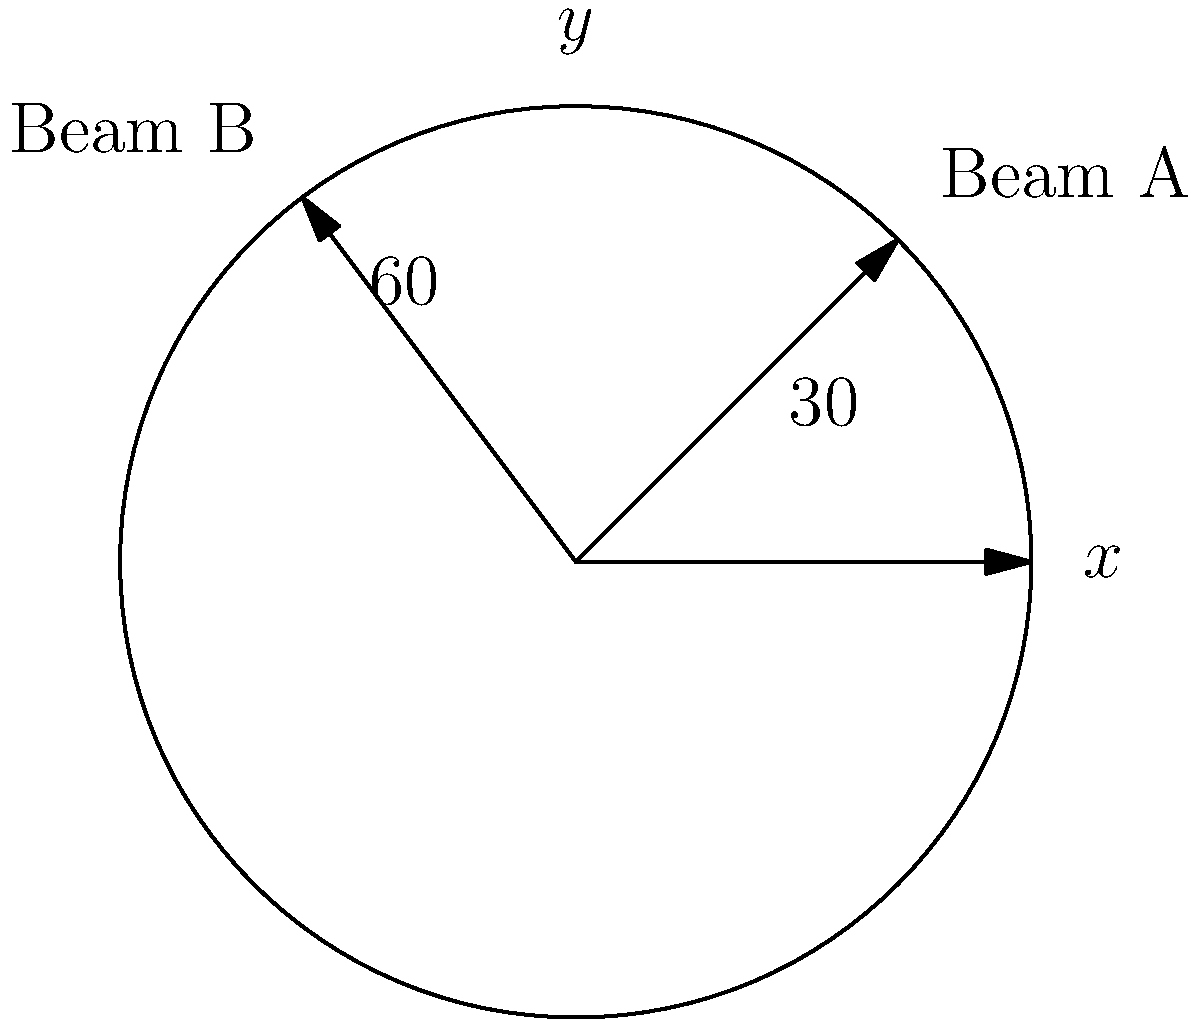Two support beams, A and B, are being installed in a circular structure. Beam A is positioned at an angle of $30°$ from the positive x-axis, while Beam B is positioned at $60°$ from the negative x-axis in the upper-left quadrant. What is the angle between these two support beams? To find the angle between the two support beams, we need to follow these steps:

1. Identify the angles of both beams from the positive x-axis:
   - Beam A: $30°$ (given)
   - Beam B: $180° - 60° = 120°$ (since it's $60°$ from the negative x-axis)

2. Calculate the difference between these angles:
   $120° - 30° = 90°$

3. The angle between the beams is the absolute value of this difference:
   $|90°| = 90°$

Therefore, the angle between the two support beams is $90°$.
Answer: $90°$ 